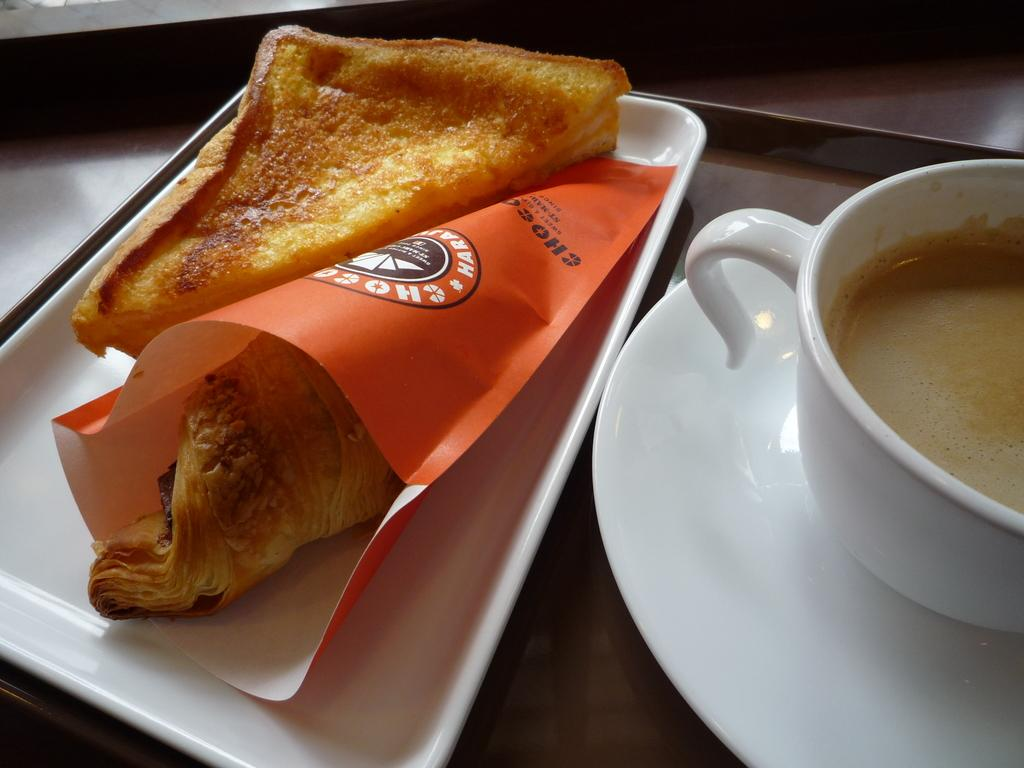What is on the plate in the image? There is a cup on the plate in the image. What else can be seen on the tray in the image? There is bread on the tray, and there is an object in an orange cover on the tray. What is the purpose of the tray in the image? The tray is likely used for holding and serving the items, such as the bread and the object in the orange cover. What type of account is being discussed in the image? There is no mention of an account in the image; it features a plate, a cup, a tray, bread, and an object in an orange cover. How is the arithmetic being used in the image? There is no arithmetic being used in the image; it is a still life of various objects on a tray. 